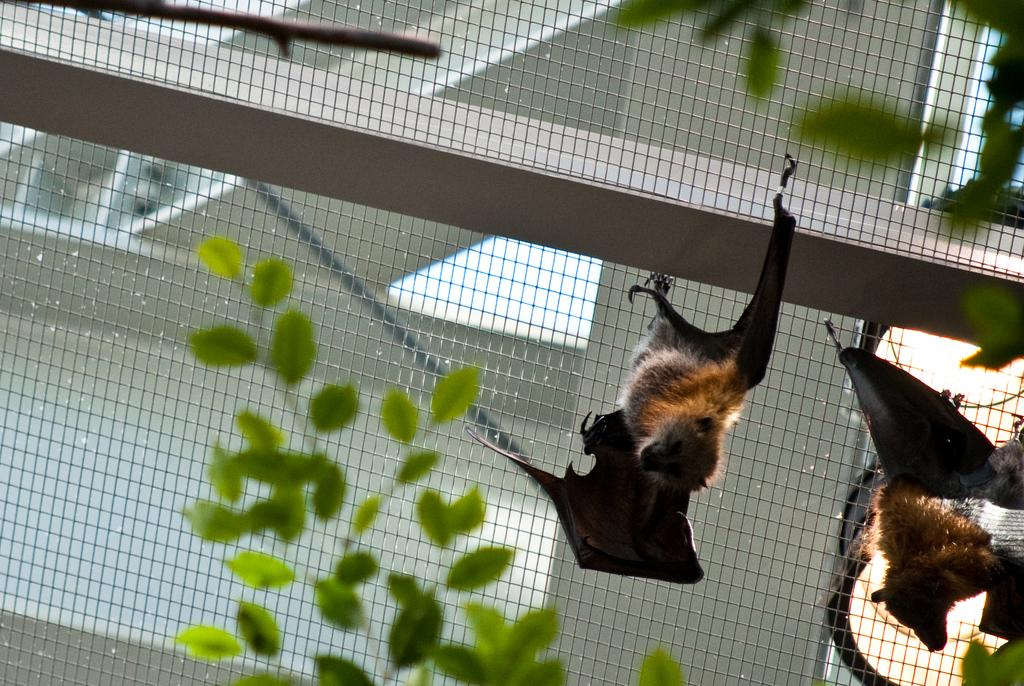What is hanging in the grill in the image? There are brown color bats hanging in the grill. What type of vegetation can be seen in the front of the image? There are green leaves in the front of the image. What color is the wall visible in the background? There is a white color wall in the background. What object can be seen on the wall in the background? There is a shelf box in the background. Can you tell me how many hospitals are visible in the image? There are no hospitals present in the image. Is there a stream flowing through the image? There is no stream visible in the image. 